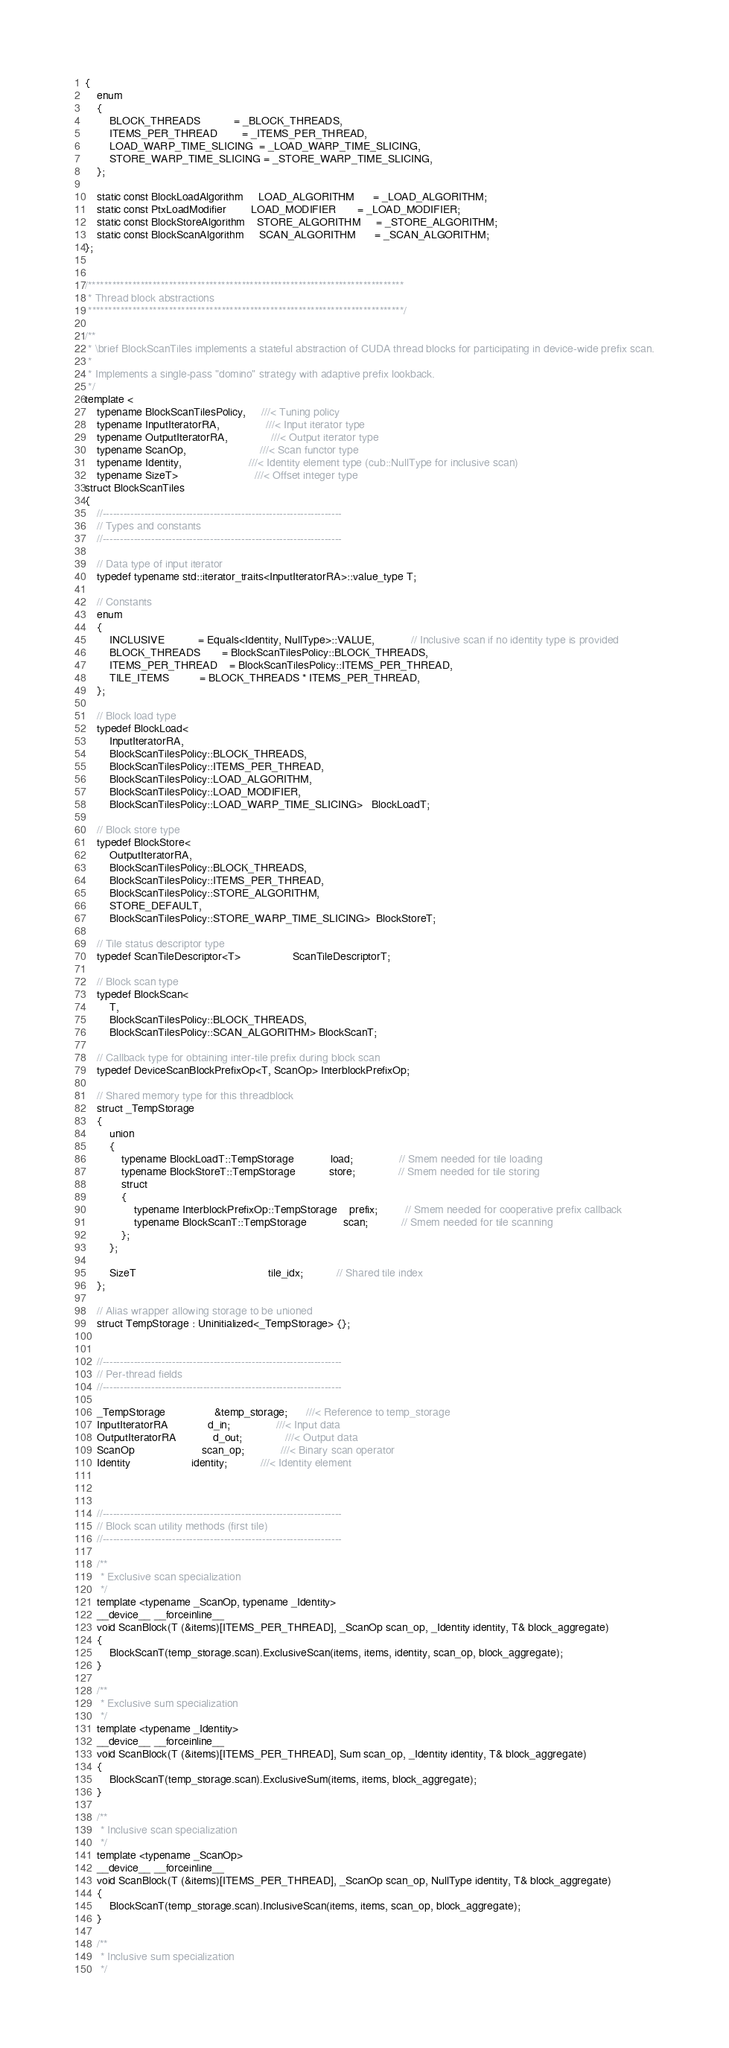<code> <loc_0><loc_0><loc_500><loc_500><_Cuda_>{
    enum
    {
        BLOCK_THREADS           = _BLOCK_THREADS,
        ITEMS_PER_THREAD        = _ITEMS_PER_THREAD,
        LOAD_WARP_TIME_SLICING  = _LOAD_WARP_TIME_SLICING,
        STORE_WARP_TIME_SLICING = _STORE_WARP_TIME_SLICING,
    };

    static const BlockLoadAlgorithm     LOAD_ALGORITHM      = _LOAD_ALGORITHM;
    static const PtxLoadModifier        LOAD_MODIFIER       = _LOAD_MODIFIER;
    static const BlockStoreAlgorithm    STORE_ALGORITHM     = _STORE_ALGORITHM;
    static const BlockScanAlgorithm     SCAN_ALGORITHM      = _SCAN_ALGORITHM;
};


/******************************************************************************
 * Thread block abstractions
 ******************************************************************************/

/**
 * \brief BlockScanTiles implements a stateful abstraction of CUDA thread blocks for participating in device-wide prefix scan.
 *
 * Implements a single-pass "domino" strategy with adaptive prefix lookback.
 */
template <
    typename BlockScanTilesPolicy,     ///< Tuning policy
    typename InputIteratorRA,               ///< Input iterator type
    typename OutputIteratorRA,              ///< Output iterator type
    typename ScanOp,                        ///< Scan functor type
    typename Identity,                      ///< Identity element type (cub::NullType for inclusive scan)
    typename SizeT>                         ///< Offset integer type
struct BlockScanTiles
{
    //---------------------------------------------------------------------
    // Types and constants
    //---------------------------------------------------------------------

    // Data type of input iterator
    typedef typename std::iterator_traits<InputIteratorRA>::value_type T;

    // Constants
    enum
    {
        INCLUSIVE           = Equals<Identity, NullType>::VALUE,            // Inclusive scan if no identity type is provided
        BLOCK_THREADS       = BlockScanTilesPolicy::BLOCK_THREADS,
        ITEMS_PER_THREAD    = BlockScanTilesPolicy::ITEMS_PER_THREAD,
        TILE_ITEMS          = BLOCK_THREADS * ITEMS_PER_THREAD,
    };

    // Block load type
    typedef BlockLoad<
        InputIteratorRA,
        BlockScanTilesPolicy::BLOCK_THREADS,
        BlockScanTilesPolicy::ITEMS_PER_THREAD,
        BlockScanTilesPolicy::LOAD_ALGORITHM,
        BlockScanTilesPolicy::LOAD_MODIFIER,
        BlockScanTilesPolicy::LOAD_WARP_TIME_SLICING>   BlockLoadT;

    // Block store type
    typedef BlockStore<
        OutputIteratorRA,
        BlockScanTilesPolicy::BLOCK_THREADS,
        BlockScanTilesPolicy::ITEMS_PER_THREAD,
        BlockScanTilesPolicy::STORE_ALGORITHM,
        STORE_DEFAULT,
        BlockScanTilesPolicy::STORE_WARP_TIME_SLICING>  BlockStoreT;

    // Tile status descriptor type
    typedef ScanTileDescriptor<T>                 ScanTileDescriptorT;

    // Block scan type
    typedef BlockScan<
        T,
        BlockScanTilesPolicy::BLOCK_THREADS,
        BlockScanTilesPolicy::SCAN_ALGORITHM> BlockScanT;

    // Callback type for obtaining inter-tile prefix during block scan
    typedef DeviceScanBlockPrefixOp<T, ScanOp> InterblockPrefixOp;

    // Shared memory type for this threadblock
    struct _TempStorage
    {
        union
        {
            typename BlockLoadT::TempStorage            load;               // Smem needed for tile loading
            typename BlockStoreT::TempStorage           store;              // Smem needed for tile storing
            struct
            {
                typename InterblockPrefixOp::TempStorage    prefix;         // Smem needed for cooperative prefix callback
                typename BlockScanT::TempStorage            scan;           // Smem needed for tile scanning
            };
        };

        SizeT                                           tile_idx;           // Shared tile index
    };

    // Alias wrapper allowing storage to be unioned
    struct TempStorage : Uninitialized<_TempStorage> {};


    //---------------------------------------------------------------------
    // Per-thread fields
    //---------------------------------------------------------------------

    _TempStorage                &temp_storage;      ///< Reference to temp_storage
    InputIteratorRA             d_in;               ///< Input data
    OutputIteratorRA            d_out;              ///< Output data
    ScanOp                      scan_op;            ///< Binary scan operator
    Identity                    identity;           ///< Identity element



    //---------------------------------------------------------------------
    // Block scan utility methods (first tile)
    //---------------------------------------------------------------------

    /**
     * Exclusive scan specialization
     */
    template <typename _ScanOp, typename _Identity>
    __device__ __forceinline__
    void ScanBlock(T (&items)[ITEMS_PER_THREAD], _ScanOp scan_op, _Identity identity, T& block_aggregate)
    {
        BlockScanT(temp_storage.scan).ExclusiveScan(items, items, identity, scan_op, block_aggregate);
    }

    /**
     * Exclusive sum specialization
     */
    template <typename _Identity>
    __device__ __forceinline__
    void ScanBlock(T (&items)[ITEMS_PER_THREAD], Sum scan_op, _Identity identity, T& block_aggregate)
    {
        BlockScanT(temp_storage.scan).ExclusiveSum(items, items, block_aggregate);
    }

    /**
     * Inclusive scan specialization
     */
    template <typename _ScanOp>
    __device__ __forceinline__
    void ScanBlock(T (&items)[ITEMS_PER_THREAD], _ScanOp scan_op, NullType identity, T& block_aggregate)
    {
        BlockScanT(temp_storage.scan).InclusiveScan(items, items, scan_op, block_aggregate);
    }

    /**
     * Inclusive sum specialization
     */</code> 